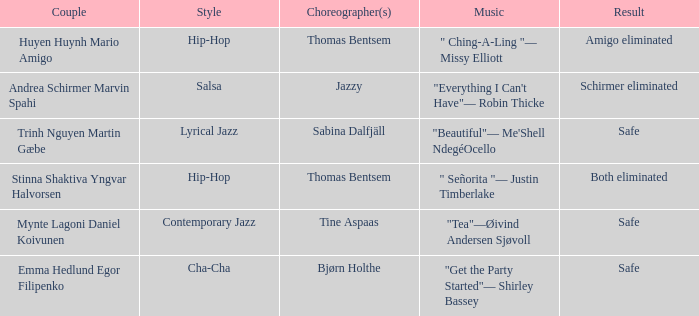What is the music for choreographer sabina dalfjäll? "Beautiful"— Me'Shell NdegéOcello. 